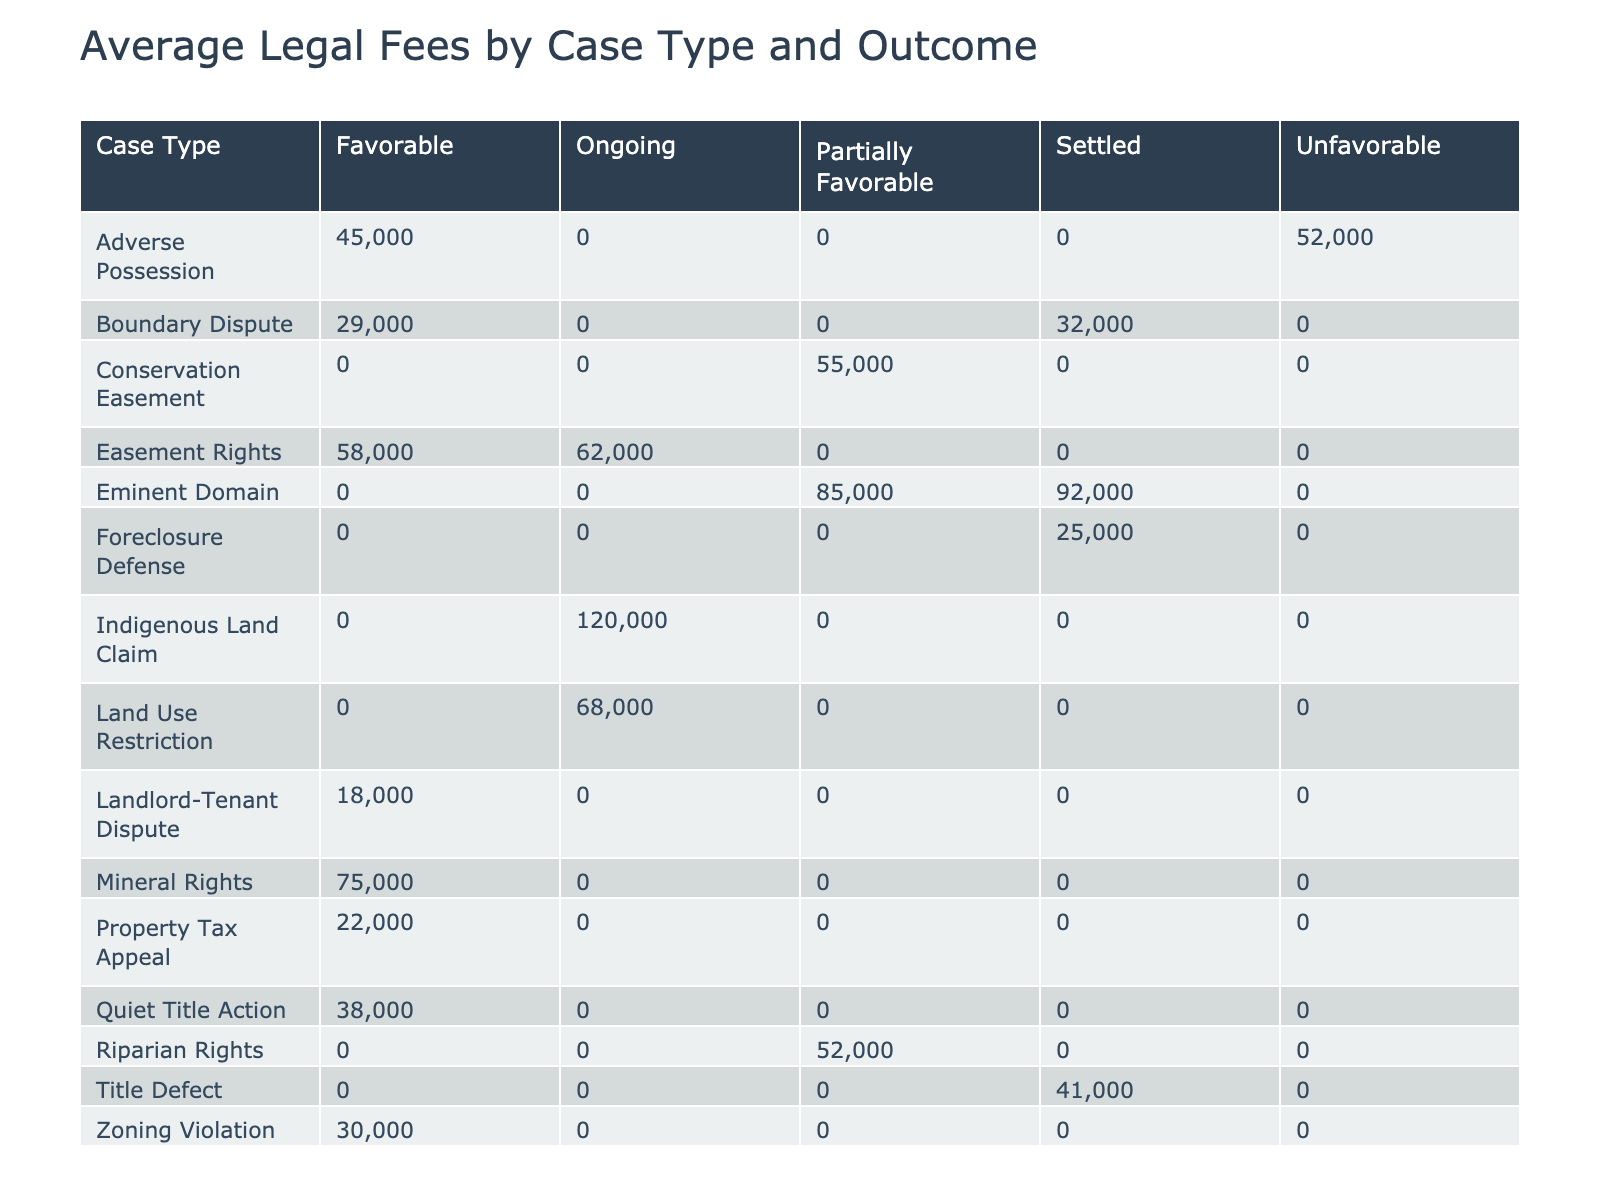What is the average legal fee for Eminent Domain cases? To find the average legal fee for Eminent Domain cases, we look at the corresponding column under the 'Eminent Domain' row in the table. There are two cases: one with a fee of 85000 and another with a fee of 92000. So, we can calculate the average as (85000 + 92000) / 2 = 88500.
Answer: 88500 Which case type has the highest average legal fee? By reviewing the average fees for each case type, we identify that the Indigenous Land Claim has the highest average fee of 120000.
Answer: 120000 Is the average legal fee for Boundary Dispute cases lower than that of Zoning Violation cases? We compare the average legal fees for Boundary Dispute (average of (32000 + 29000)/2 = 30500) and Zoning Violation (average of (28000 + 31000)/2 = 29500). Since 30500 is greater than 29500, the average legal fee for Boundary Dispute is higher.
Answer: No What is the average legal fee for cases with a favorable outcome? We need to identify all case types with favorable outcomes and calculate their total legal fees. The total for favorable outcomes is 45000 (Adverse Possession) + 32000 (Boundary Dispute) + 58000 (Easement Rights) + 28000 (Zoning Violation) + 41000 (Title Defect) + 18000 (Landlord-Tenant Dispute) + 22000 (Property Tax Appeal) + 38000 (Quiet Title Action) + 55000 (Conservation Easement) = 295000. There are 9 cases, so we find the average by dividing 295000 by 9, which results in approximately 32777.78 (rounded to 33000).
Answer: 33000 How many case types have an ongoing outcome? Examining the table, we see that Indigenous Land Claim, Land Use Restriction, and Easement Rights are the only cases listed with an ongoing outcome. Therefore, there are 3 case types with an ongoing outcome.
Answer: 3 